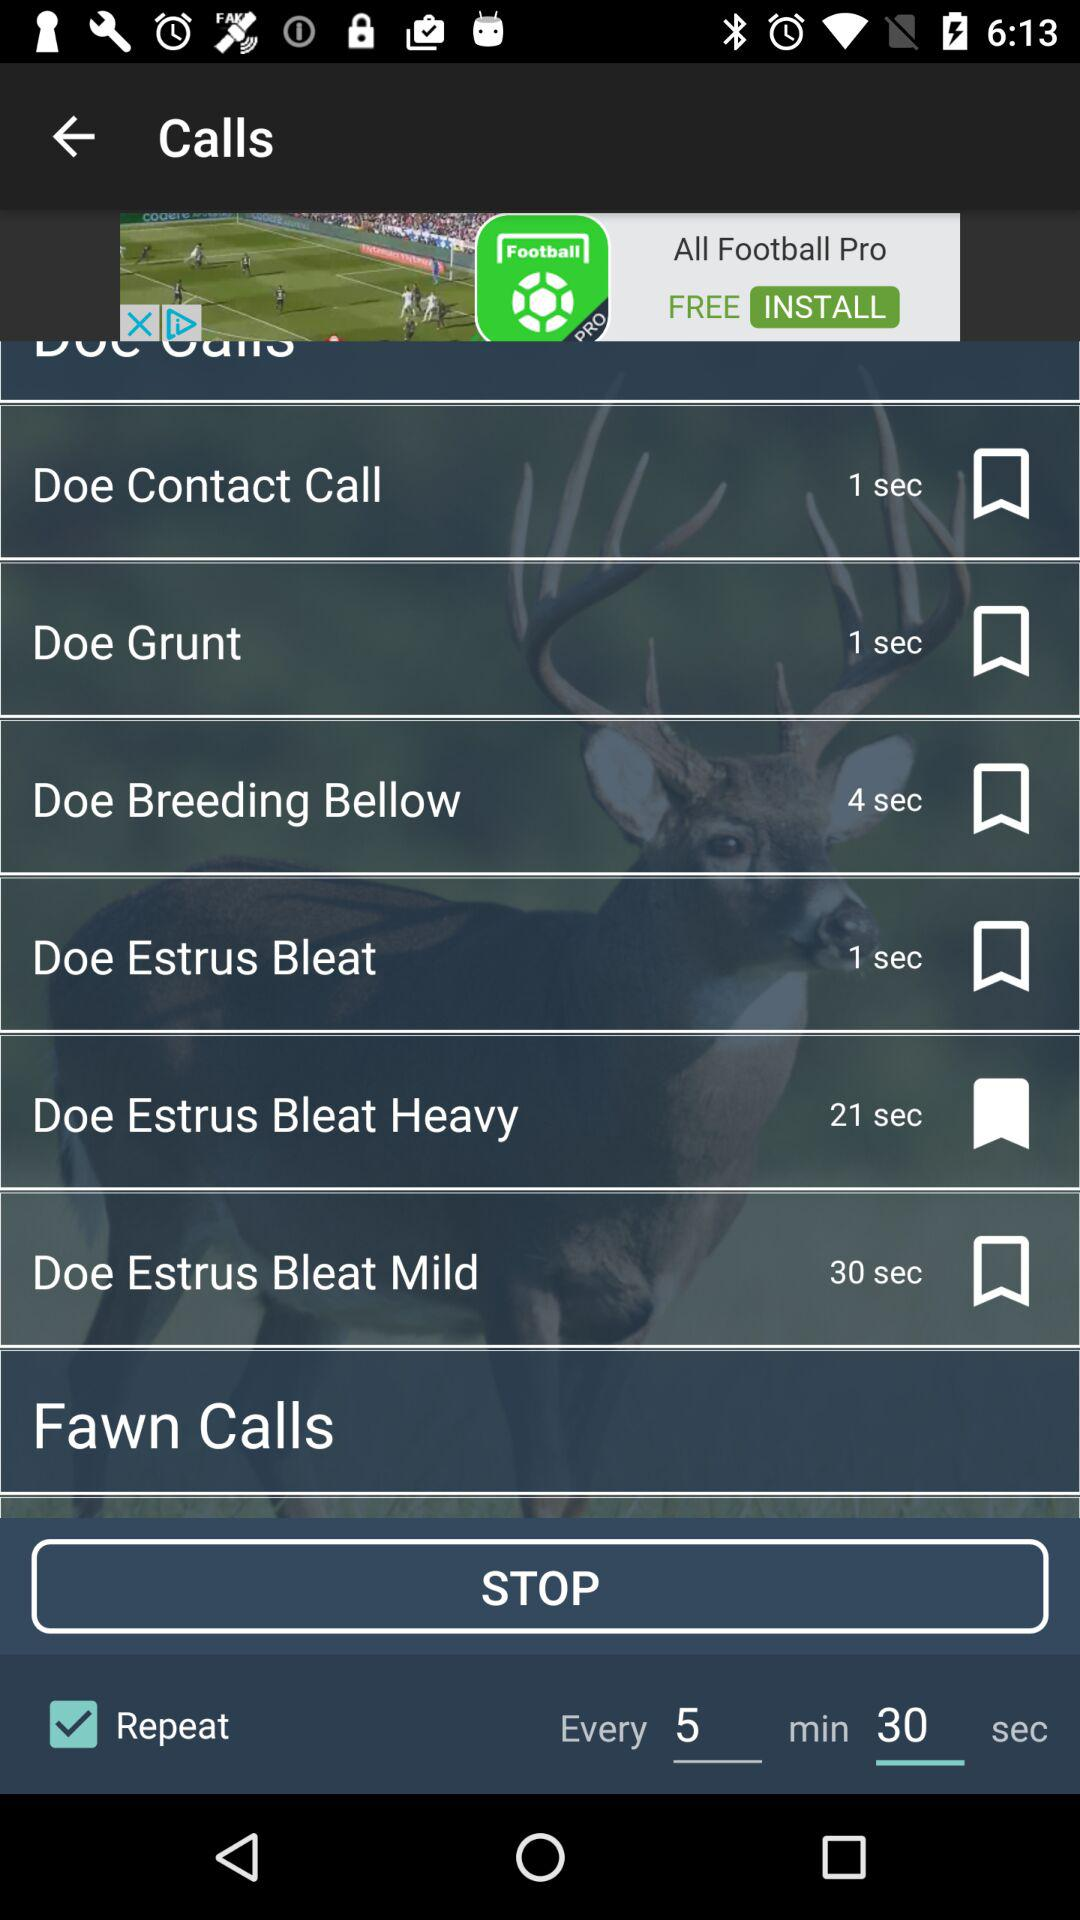What option is bookmarked? The bookmarked option is "Doe Estrus Bleat Heavy". 